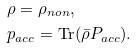<formula> <loc_0><loc_0><loc_500><loc_500>& \rho = \rho _ { n o n } , \\ & p _ { a c c } = \text {Tr} ( \bar { \rho } P _ { a c c } ) .</formula> 